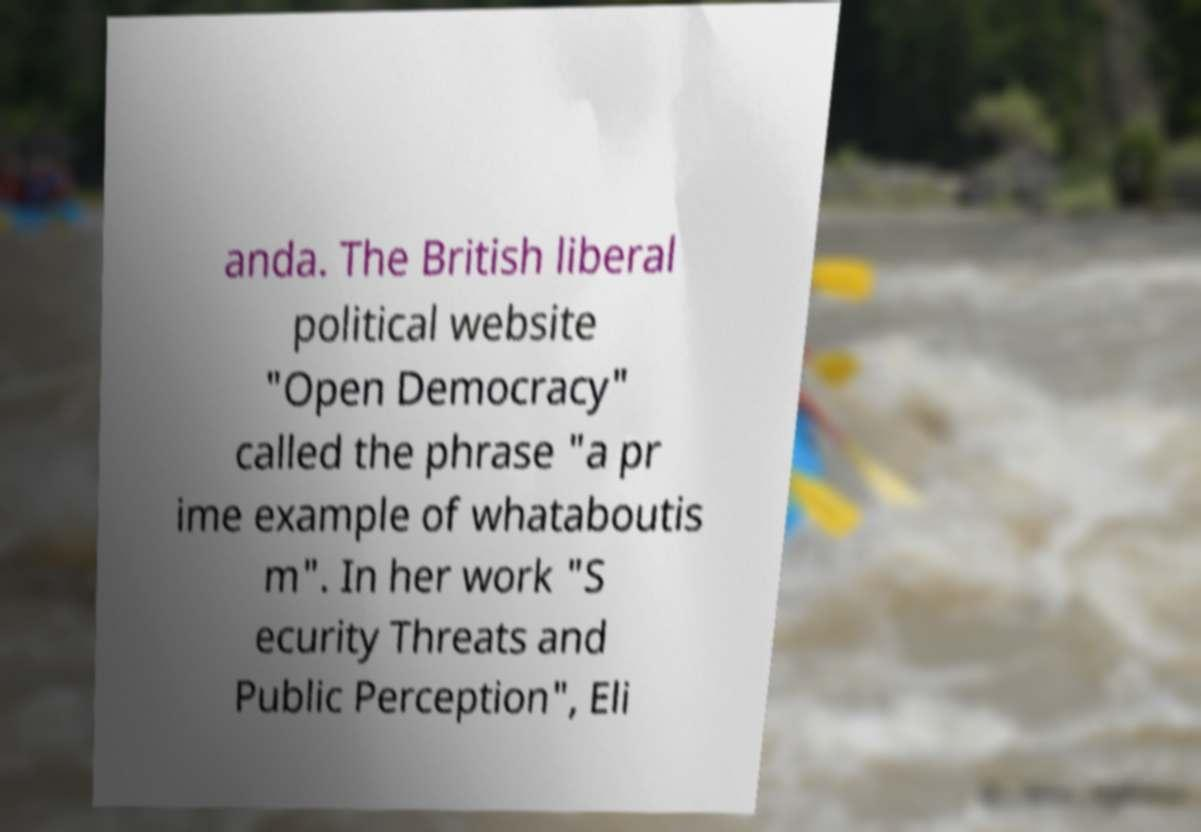For documentation purposes, I need the text within this image transcribed. Could you provide that? anda. The British liberal political website "Open Democracy" called the phrase "a pr ime example of whataboutis m". In her work "S ecurity Threats and Public Perception", Eli 